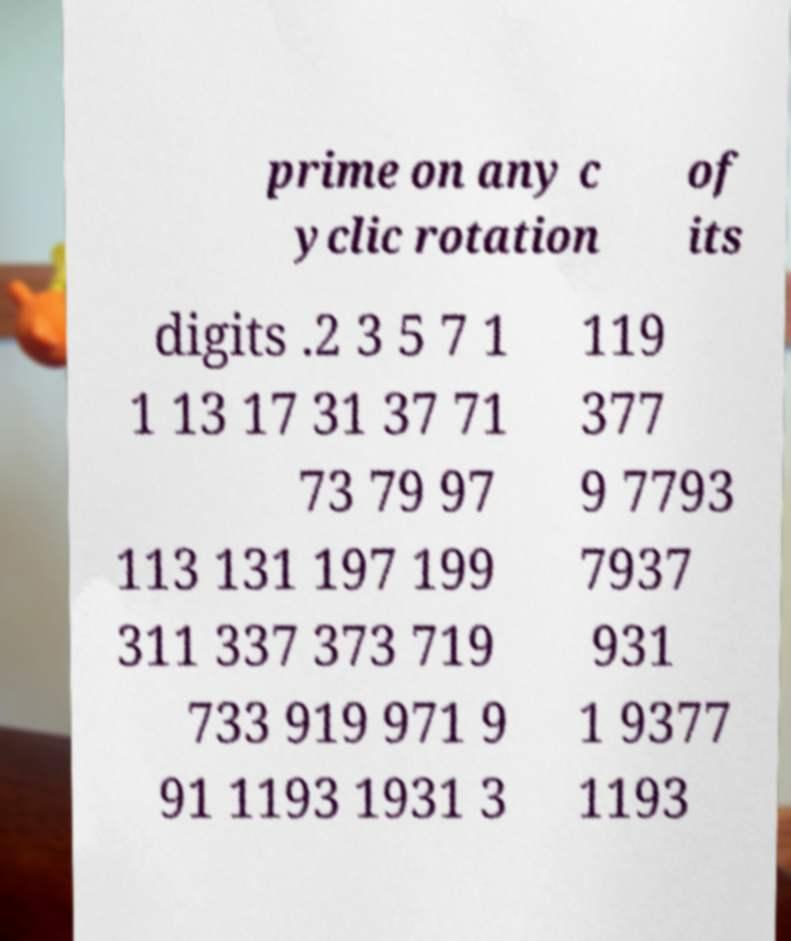What messages or text are displayed in this image? I need them in a readable, typed format. prime on any c yclic rotation of its digits .2 3 5 7 1 1 13 17 31 37 71 73 79 97 113 131 197 199 311 337 373 719 733 919 971 9 91 1193 1931 3 119 377 9 7793 7937 931 1 9377 1193 